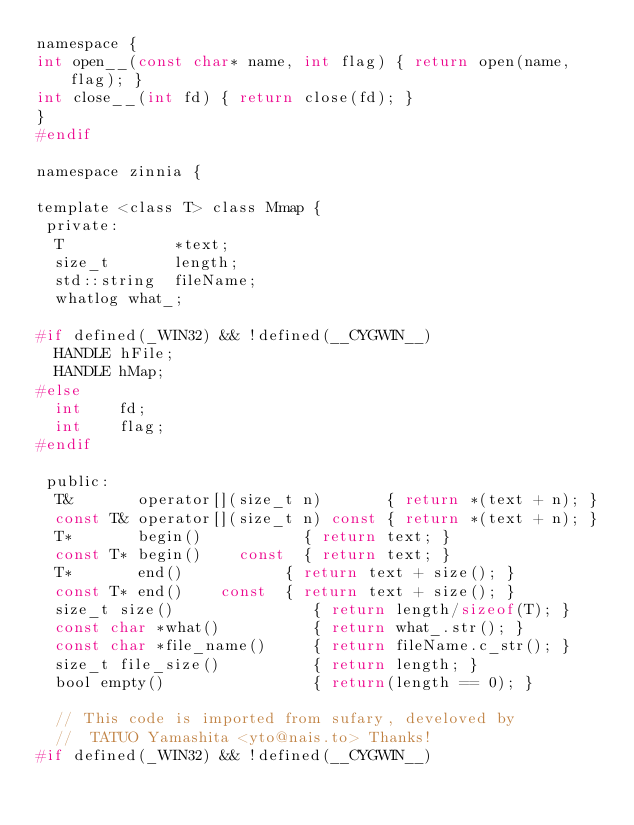Convert code to text. <code><loc_0><loc_0><loc_500><loc_500><_C_>namespace {
int open__(const char* name, int flag) { return open(name, flag); }
int close__(int fd) { return close(fd); }
}
#endif

namespace zinnia {

template <class T> class Mmap {
 private:
  T            *text;
  size_t       length;
  std::string  fileName;
  whatlog what_;

#if defined(_WIN32) && !defined(__CYGWIN__)
  HANDLE hFile;
  HANDLE hMap;
#else
  int    fd;
  int    flag;
#endif

 public:
  T&       operator[](size_t n)       { return *(text + n); }
  const T& operator[](size_t n) const { return *(text + n); }
  T*       begin()           { return text; }
  const T* begin()    const  { return text; }
  T*       end()           { return text + size(); }
  const T* end()    const  { return text + size(); }
  size_t size()               { return length/sizeof(T); }
  const char *what()          { return what_.str(); }
  const char *file_name()     { return fileName.c_str(); }
  size_t file_size()          { return length; }
  bool empty()                { return(length == 0); }

  // This code is imported from sufary, develoved by
  //  TATUO Yamashita <yto@nais.to> Thanks!
#if defined(_WIN32) && !defined(__CYGWIN__)</code> 